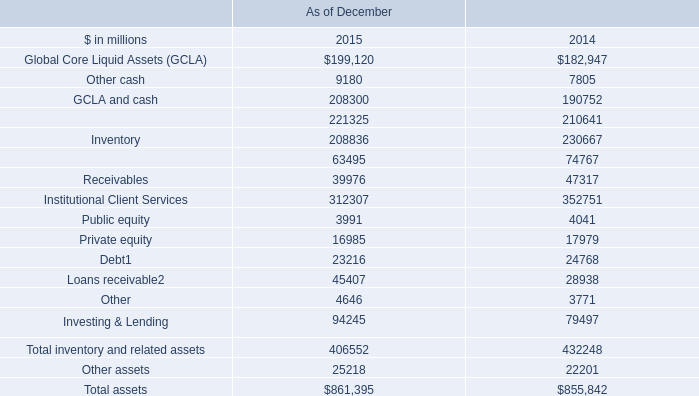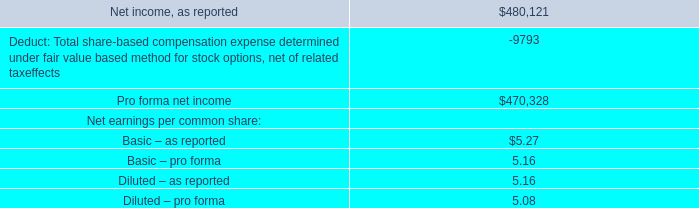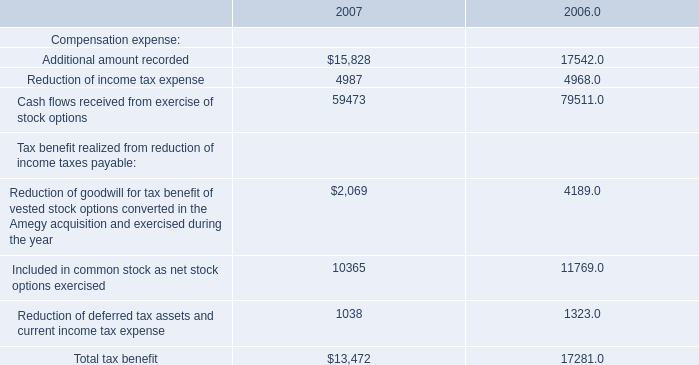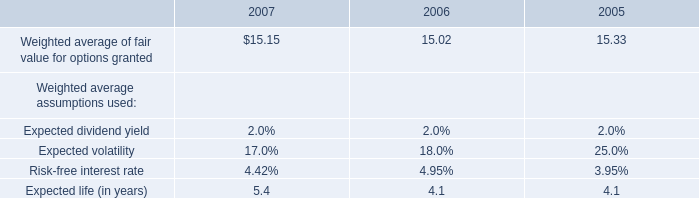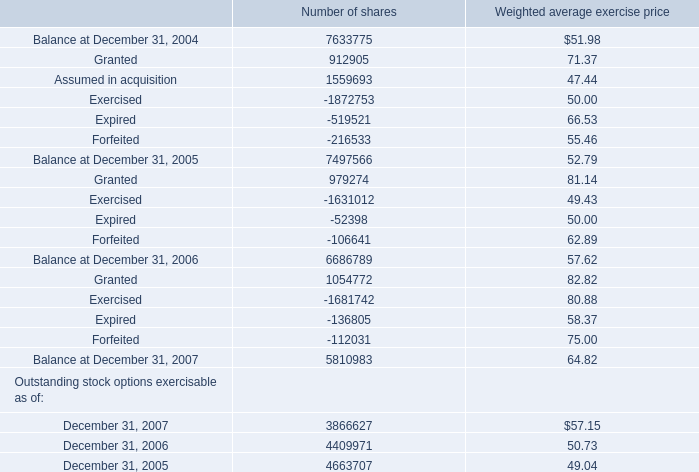What will for Expired Number of shares be like in 2008 if it develops with the same increasing rate as current? 
Computations: ((((-136805 + 52398) / -52398) + 1) * -136805)
Answer: -357181.72497. 